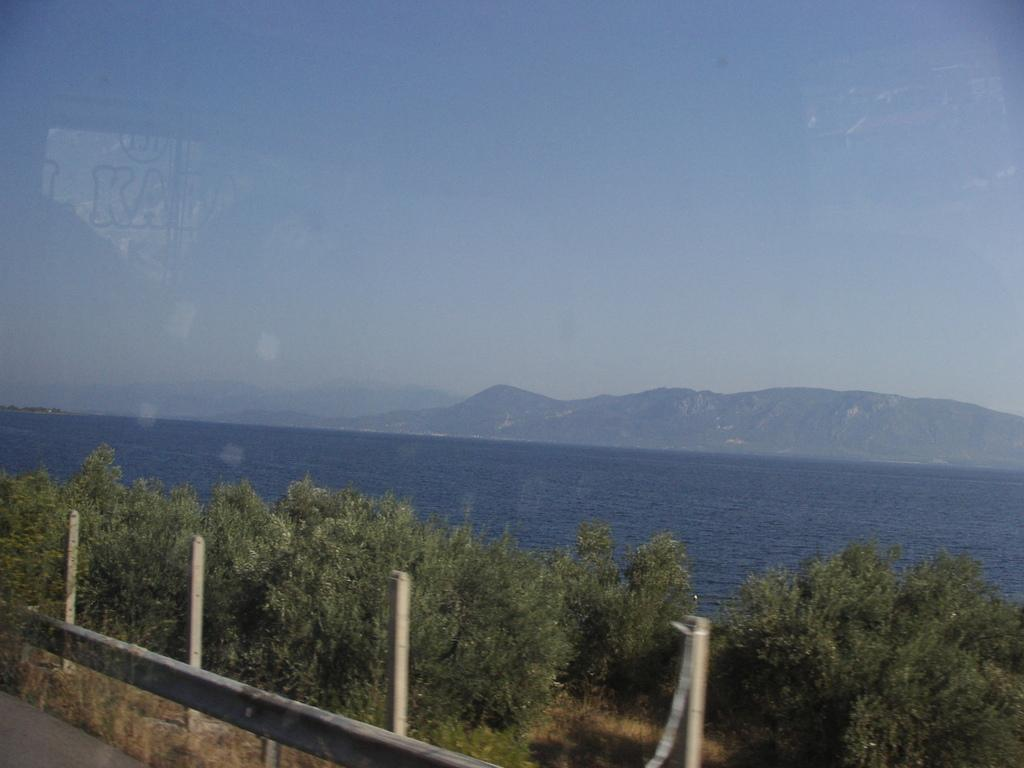What type of vegetation can be seen in the middle of the image? There are trees in the middle of the image. What natural element is visible in the image? Water is visible in the image. What type of landscape can be seen in the background of the image? There are hills in the background of the image. What flavor of peace is depicted in the image? There is no depiction of peace in the image, as it features trees, water, and hills. How is the water being used in the image? The image does not show the water being used for any specific purpose; it is simply visible in the scene. 